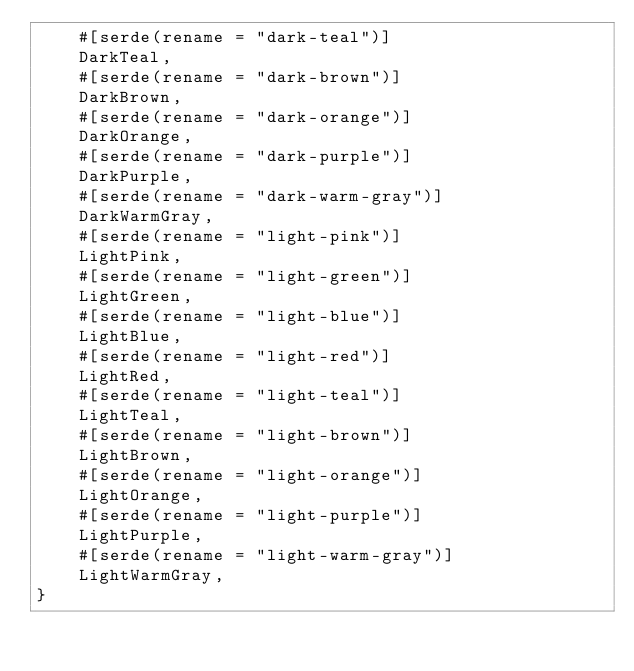Convert code to text. <code><loc_0><loc_0><loc_500><loc_500><_Rust_>    #[serde(rename = "dark-teal")]
    DarkTeal,
    #[serde(rename = "dark-brown")]
    DarkBrown,
    #[serde(rename = "dark-orange")]
    DarkOrange,
    #[serde(rename = "dark-purple")]
    DarkPurple,
    #[serde(rename = "dark-warm-gray")]
    DarkWarmGray,
    #[serde(rename = "light-pink")]
    LightPink,
    #[serde(rename = "light-green")]
    LightGreen,
    #[serde(rename = "light-blue")]
    LightBlue,
    #[serde(rename = "light-red")]
    LightRed,
    #[serde(rename = "light-teal")]
    LightTeal,
    #[serde(rename = "light-brown")]
    LightBrown,
    #[serde(rename = "light-orange")]
    LightOrange,
    #[serde(rename = "light-purple")]
    LightPurple,
    #[serde(rename = "light-warm-gray")]
    LightWarmGray,
}
</code> 